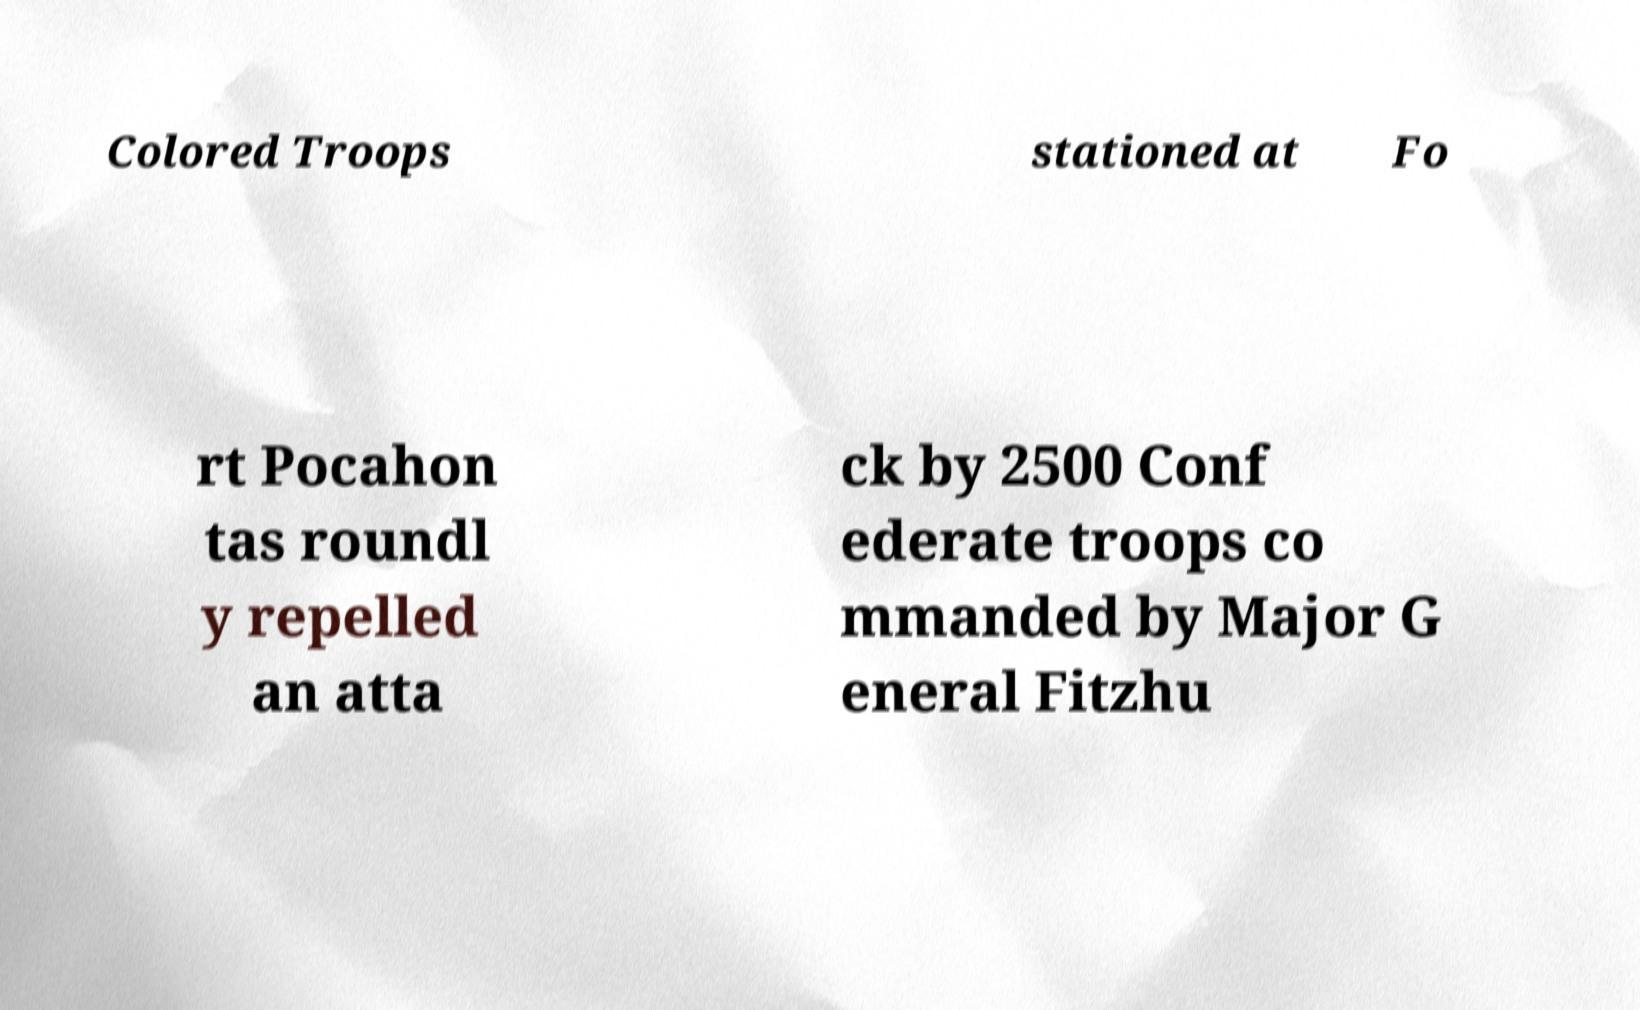I need the written content from this picture converted into text. Can you do that? Colored Troops stationed at Fo rt Pocahon tas roundl y repelled an atta ck by 2500 Conf ederate troops co mmanded by Major G eneral Fitzhu 